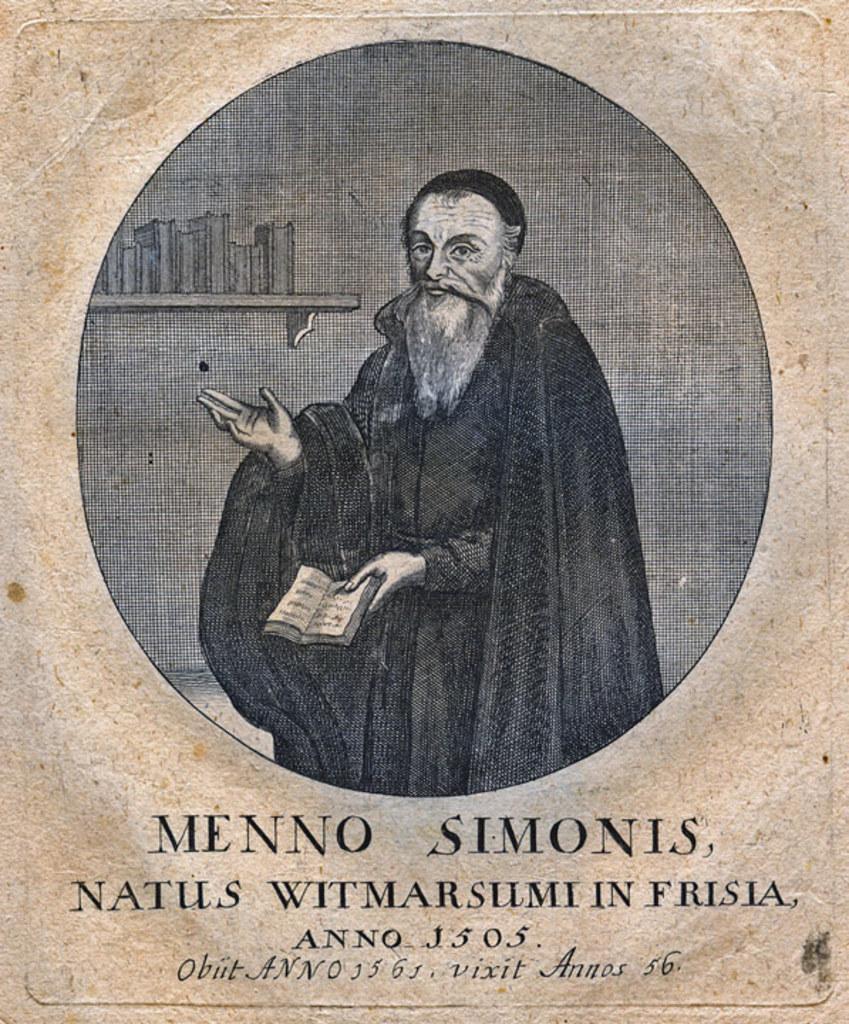Please provide a concise description of this image. In this image there is a photo of a man, at the bottom there is some text. 